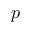Convert formula to latex. <formula><loc_0><loc_0><loc_500><loc_500>p</formula> 